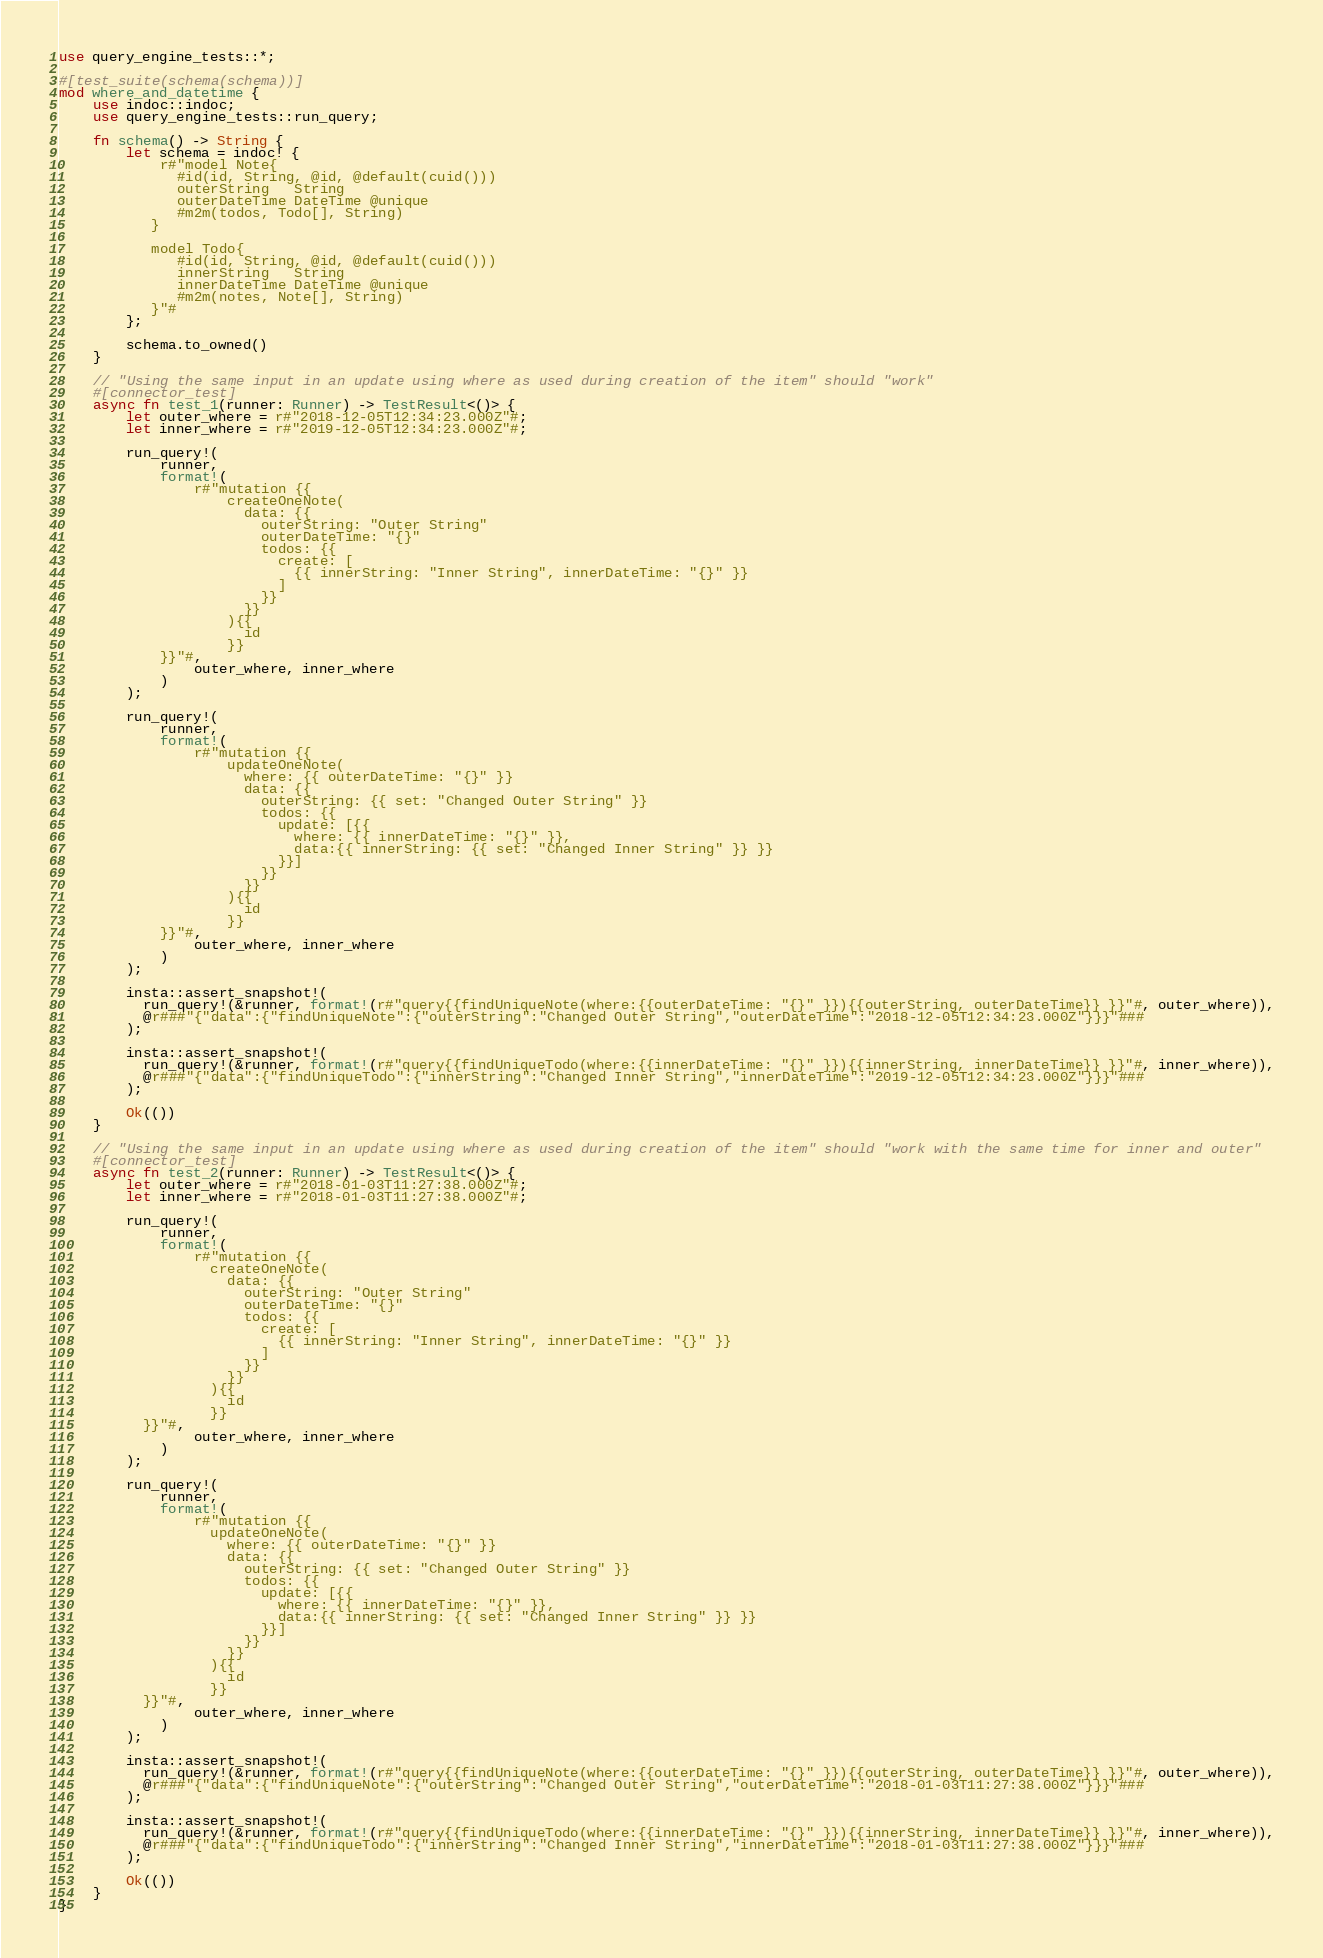Convert code to text. <code><loc_0><loc_0><loc_500><loc_500><_Rust_>use query_engine_tests::*;

#[test_suite(schema(schema))]
mod where_and_datetime {
    use indoc::indoc;
    use query_engine_tests::run_query;

    fn schema() -> String {
        let schema = indoc! {
            r#"model Note{
              #id(id, String, @id, @default(cuid()))
              outerString   String
              outerDateTime DateTime @unique
              #m2m(todos, Todo[], String)
           }

           model Todo{
              #id(id, String, @id, @default(cuid()))
              innerString   String
              innerDateTime DateTime @unique
              #m2m(notes, Note[], String)
           }"#
        };

        schema.to_owned()
    }

    // "Using the same input in an update using where as used during creation of the item" should "work"
    #[connector_test]
    async fn test_1(runner: Runner) -> TestResult<()> {
        let outer_where = r#"2018-12-05T12:34:23.000Z"#;
        let inner_where = r#"2019-12-05T12:34:23.000Z"#;

        run_query!(
            runner,
            format!(
                r#"mutation {{
                    createOneNote(
                      data: {{
                        outerString: "Outer String"
                        outerDateTime: "{}"
                        todos: {{
                          create: [
                            {{ innerString: "Inner String", innerDateTime: "{}" }}
                          ]
                        }}
                      }}
                    ){{
                      id
                    }}
            }}"#,
                outer_where, inner_where
            )
        );

        run_query!(
            runner,
            format!(
                r#"mutation {{
                    updateOneNote(
                      where: {{ outerDateTime: "{}" }}
                      data: {{
                        outerString: {{ set: "Changed Outer String" }}
                        todos: {{
                          update: [{{
                            where: {{ innerDateTime: "{}" }},
                            data:{{ innerString: {{ set: "Changed Inner String" }} }}
                          }}]
                        }}
                      }}
                    ){{
                      id
                    }}
            }}"#,
                outer_where, inner_where
            )
        );

        insta::assert_snapshot!(
          run_query!(&runner, format!(r#"query{{findUniqueNote(where:{{outerDateTime: "{}" }}){{outerString, outerDateTime}} }}"#, outer_where)),
          @r###"{"data":{"findUniqueNote":{"outerString":"Changed Outer String","outerDateTime":"2018-12-05T12:34:23.000Z"}}}"###
        );

        insta::assert_snapshot!(
          run_query!(&runner, format!(r#"query{{findUniqueTodo(where:{{innerDateTime: "{}" }}){{innerString, innerDateTime}} }}"#, inner_where)),
          @r###"{"data":{"findUniqueTodo":{"innerString":"Changed Inner String","innerDateTime":"2019-12-05T12:34:23.000Z"}}}"###
        );

        Ok(())
    }

    // "Using the same input in an update using where as used during creation of the item" should "work with the same time for inner and outer"
    #[connector_test]
    async fn test_2(runner: Runner) -> TestResult<()> {
        let outer_where = r#"2018-01-03T11:27:38.000Z"#;
        let inner_where = r#"2018-01-03T11:27:38.000Z"#;

        run_query!(
            runner,
            format!(
                r#"mutation {{
                  createOneNote(
                    data: {{
                      outerString: "Outer String"
                      outerDateTime: "{}"
                      todos: {{
                        create: [
                          {{ innerString: "Inner String", innerDateTime: "{}" }}
                        ]
                      }}
                    }}
                  ){{
                    id
                  }}
          }}"#,
                outer_where, inner_where
            )
        );

        run_query!(
            runner,
            format!(
                r#"mutation {{
                  updateOneNote(
                    where: {{ outerDateTime: "{}" }}
                    data: {{
                      outerString: {{ set: "Changed Outer String" }}
                      todos: {{
                        update: [{{
                          where: {{ innerDateTime: "{}" }},
                          data:{{ innerString: {{ set: "Changed Inner String" }} }}
                        }}]
                      }}
                    }}
                  ){{
                    id
                  }}
          }}"#,
                outer_where, inner_where
            )
        );

        insta::assert_snapshot!(
          run_query!(&runner, format!(r#"query{{findUniqueNote(where:{{outerDateTime: "{}" }}){{outerString, outerDateTime}} }}"#, outer_where)),
          @r###"{"data":{"findUniqueNote":{"outerString":"Changed Outer String","outerDateTime":"2018-01-03T11:27:38.000Z"}}}"###
        );

        insta::assert_snapshot!(
          run_query!(&runner, format!(r#"query{{findUniqueTodo(where:{{innerDateTime: "{}" }}){{innerString, innerDateTime}} }}"#, inner_where)),
          @r###"{"data":{"findUniqueTodo":{"innerString":"Changed Inner String","innerDateTime":"2018-01-03T11:27:38.000Z"}}}"###
        );

        Ok(())
    }
}
</code> 